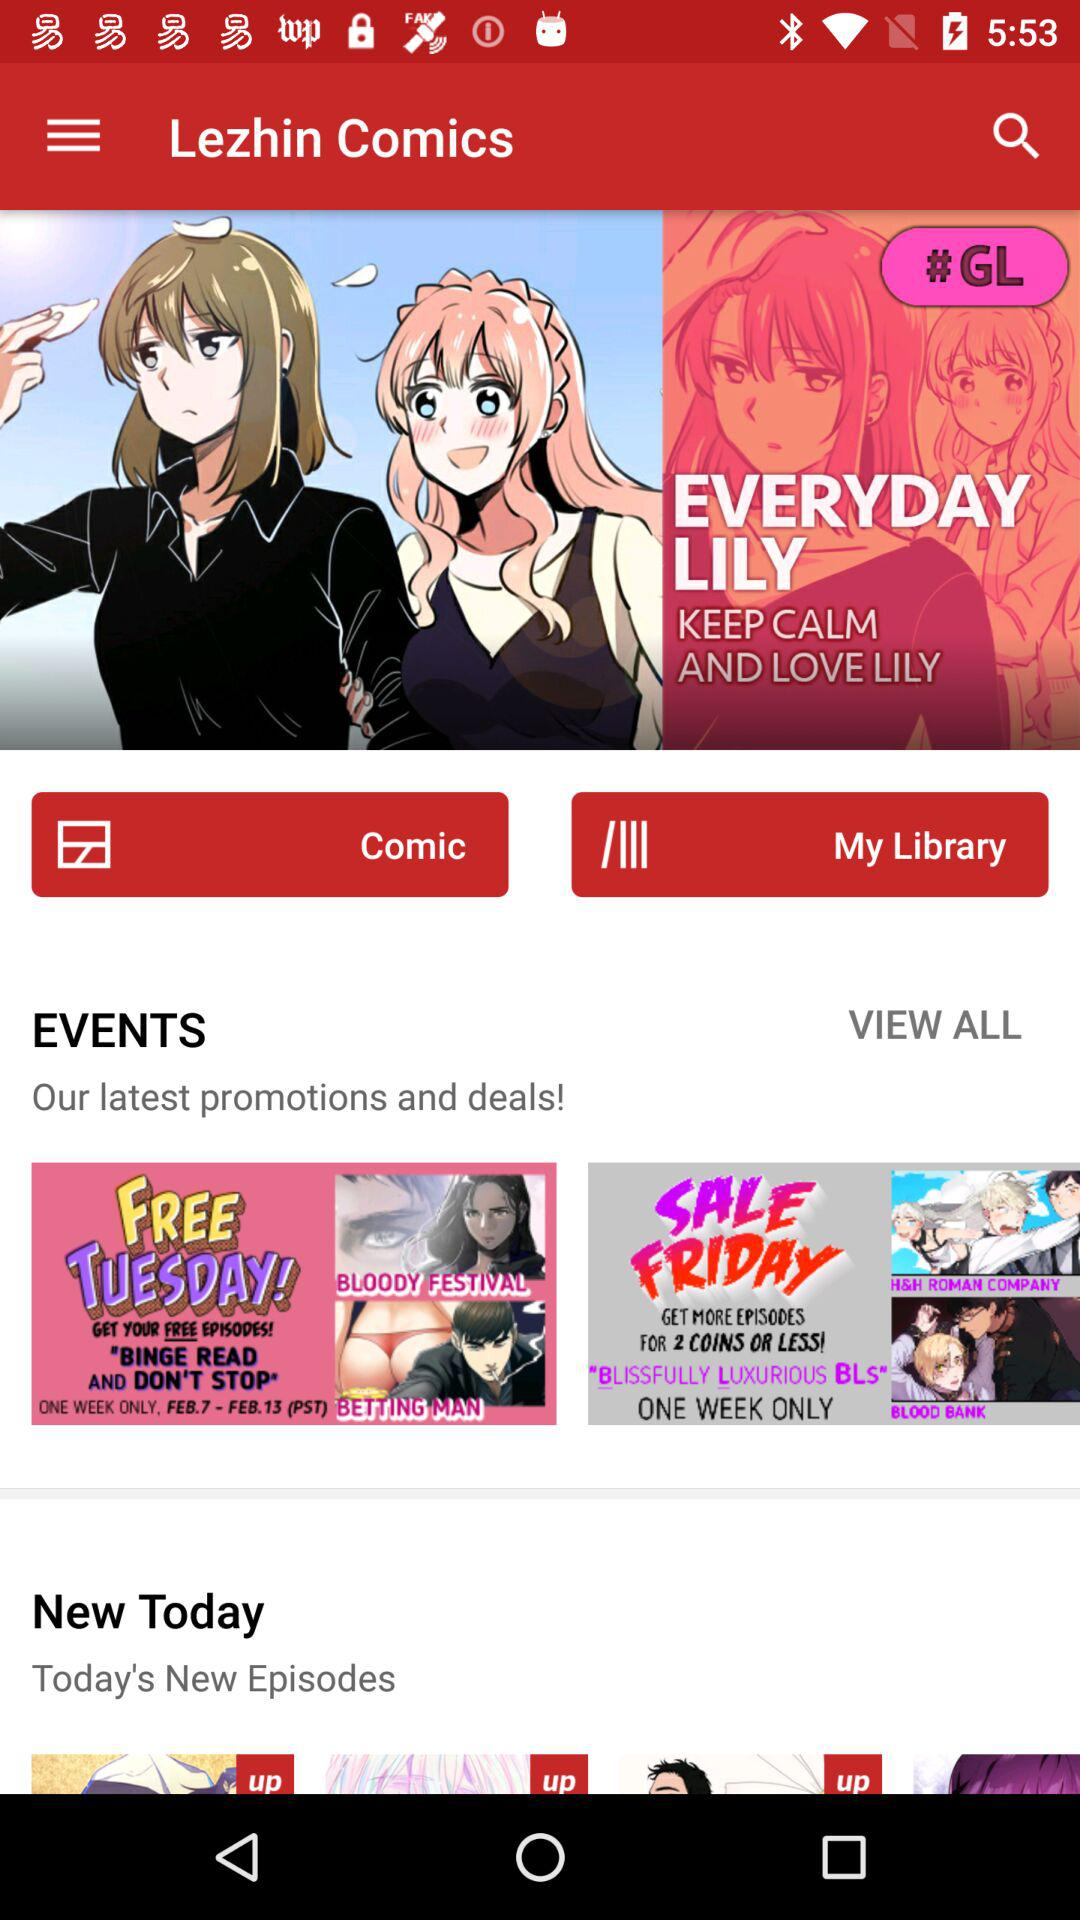What is the app name? The app name is "Lezhin Comics". 